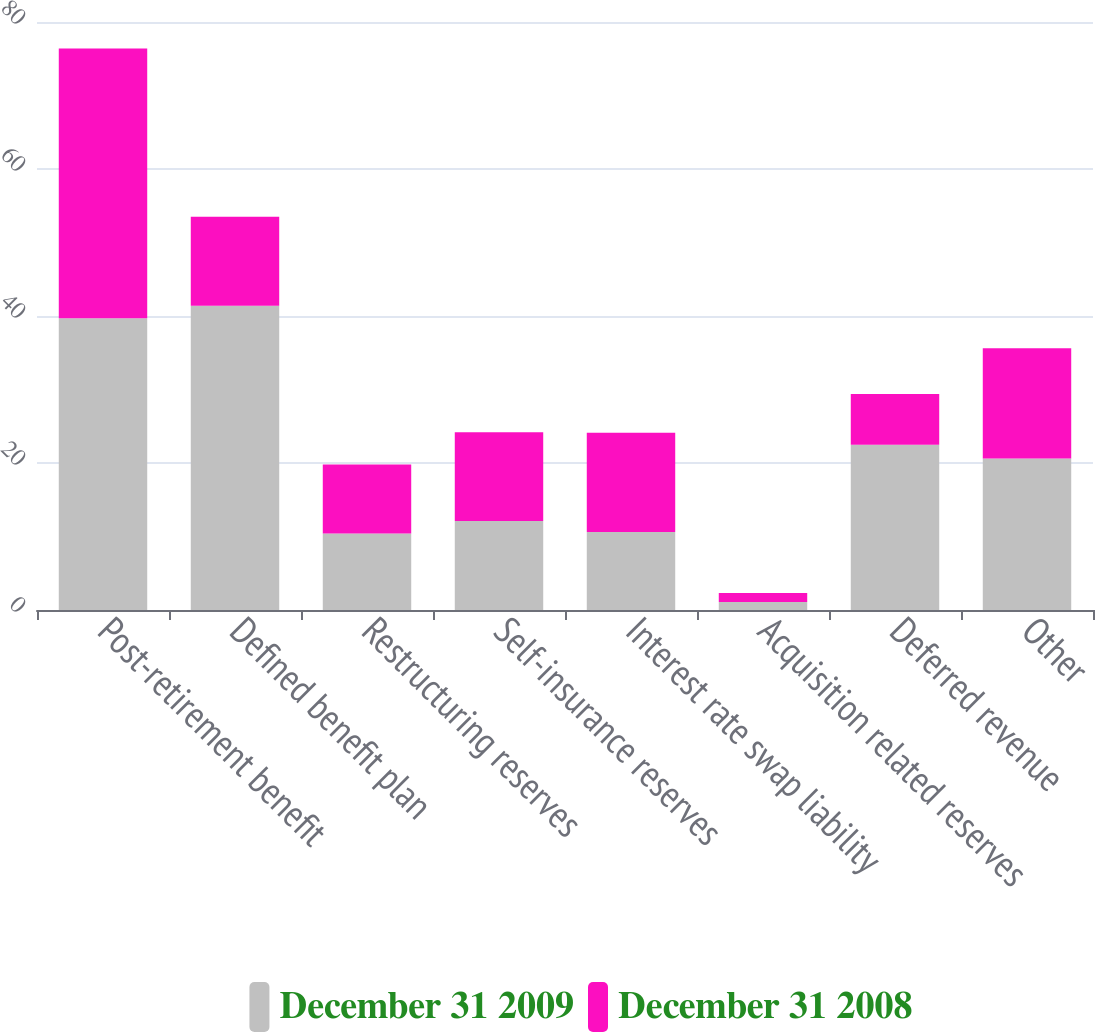Convert chart to OTSL. <chart><loc_0><loc_0><loc_500><loc_500><stacked_bar_chart><ecel><fcel>Post-retirement benefit<fcel>Defined benefit plan<fcel>Restructuring reserves<fcel>Self-insurance reserves<fcel>Interest rate swap liability<fcel>Acquisition related reserves<fcel>Deferred revenue<fcel>Other<nl><fcel>December 31 2009<fcel>39.7<fcel>41.4<fcel>10.4<fcel>12.1<fcel>10.6<fcel>1.1<fcel>22.5<fcel>20.6<nl><fcel>December 31 2008<fcel>36.7<fcel>12.1<fcel>9.4<fcel>12.1<fcel>13.5<fcel>1.2<fcel>6.9<fcel>15<nl></chart> 